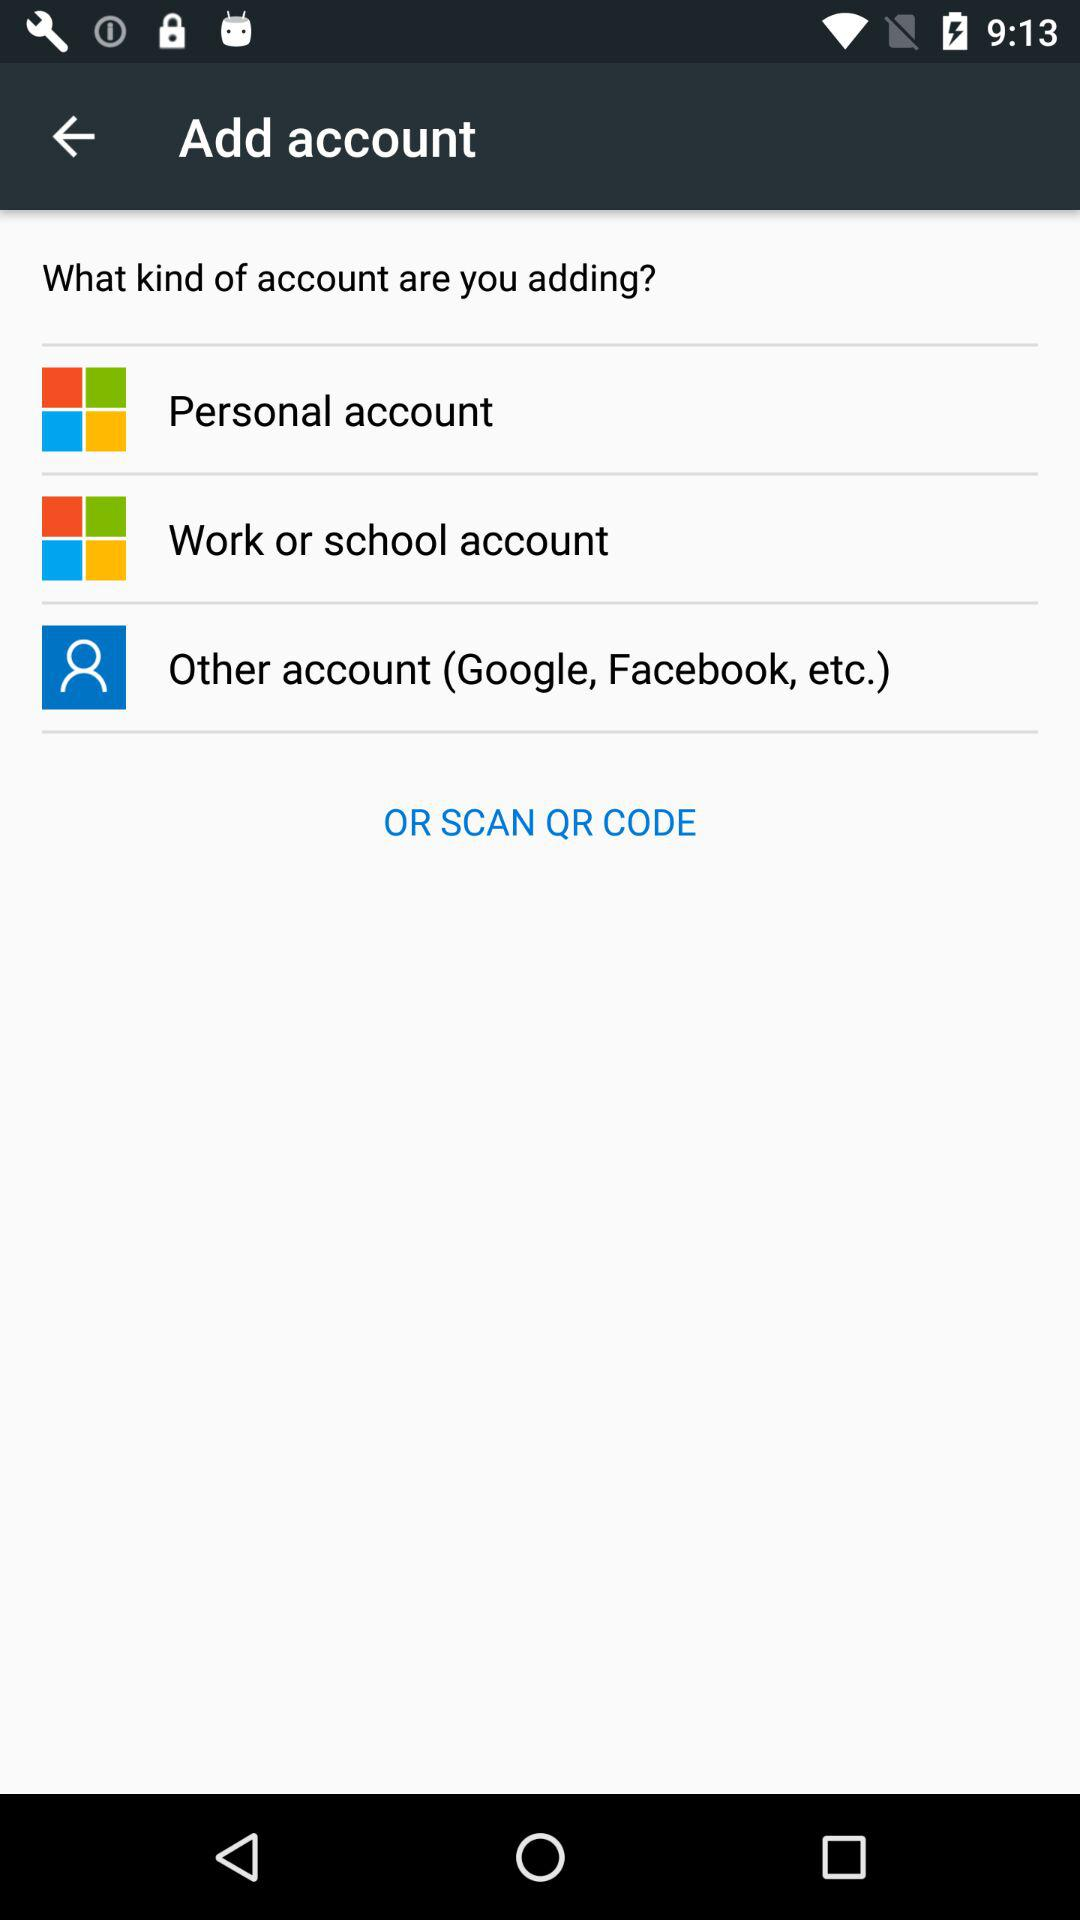What kinds of accounts are there to add? The kinds of accounts are "Personal account", "Work or school account" and "Other account". 